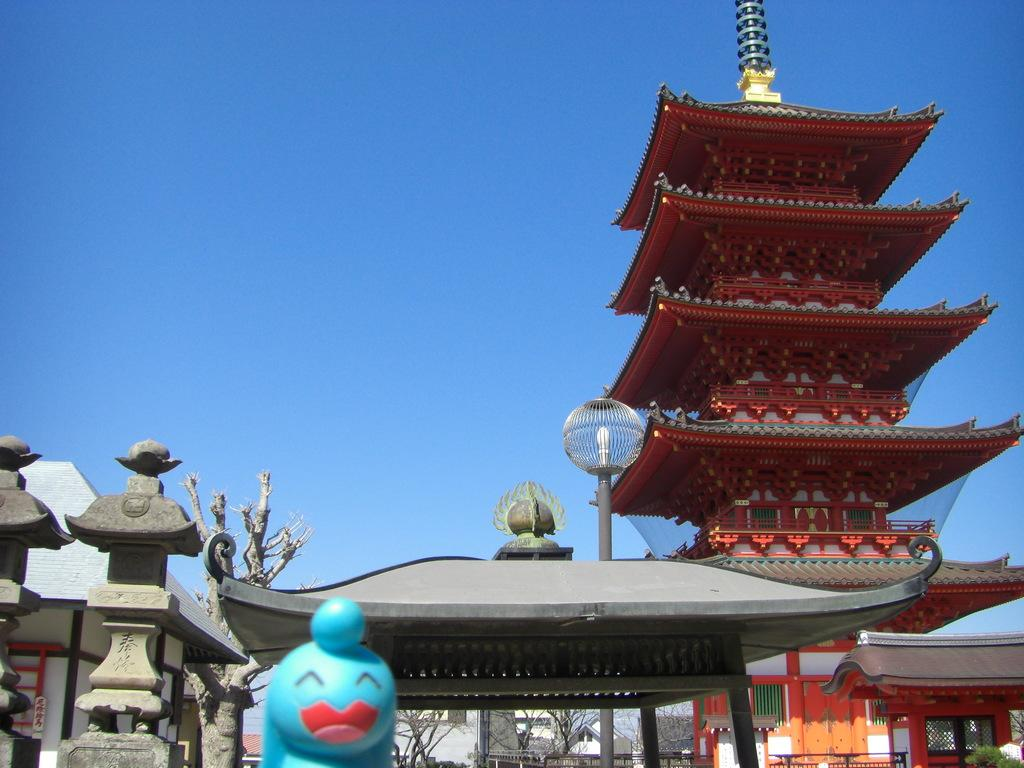What type of building is depicted in the image? There is a red color wooden Chinese temple in the image. What is located in front of the temple? There is a grey color shade with a lamp post in the front of the temple. Are there any architectural features beside the temple? Yes, there are two pillars beside the temple. What other item can be seen in the image? There is a blue color toy in the image. How many rabbits can be seen playing with the blue color toy in the image? There are no rabbits present in the image; it only features a blue color toy. What type of memory is stored in the temple in the image? The image does not depict any memory being stored in the temple; it is a physical structure. 